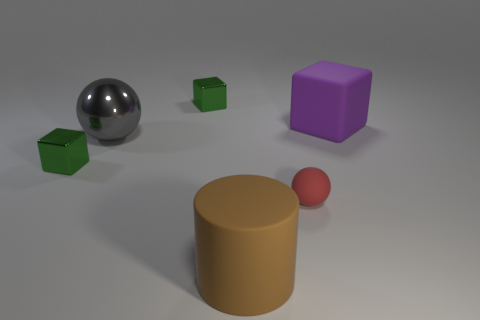What color is the tiny rubber object that is the same shape as the large gray object? The small rubber object sharing the shape with the large gray sphere is red in color. 